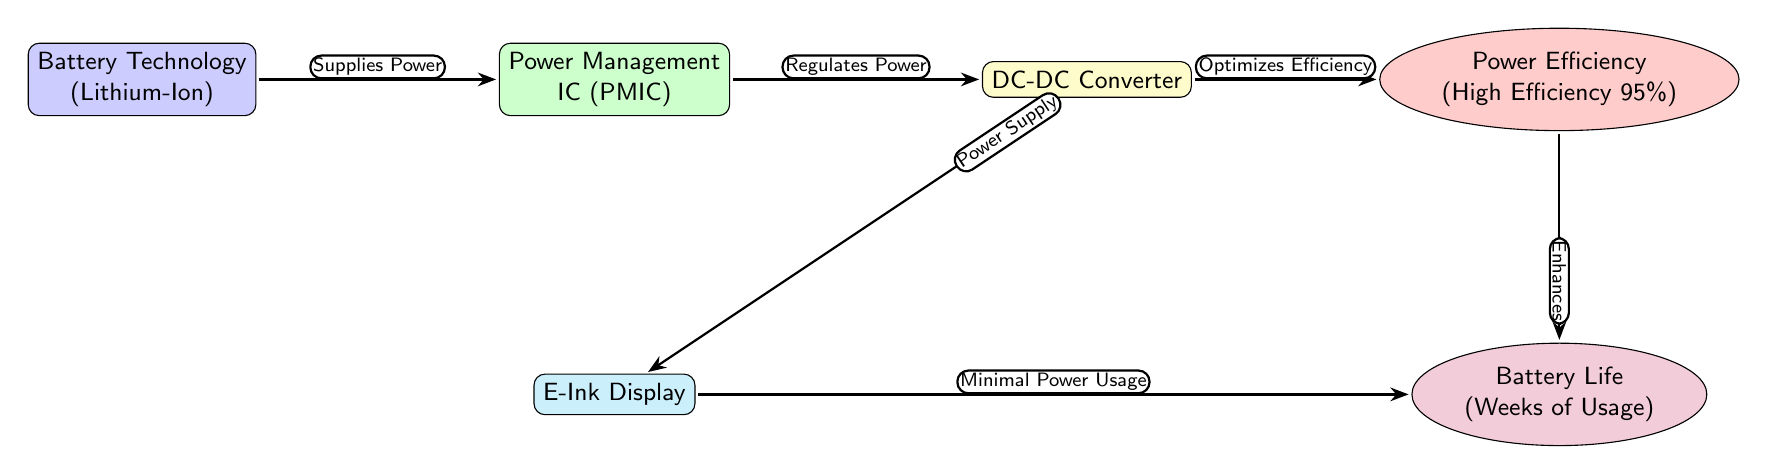What is the technology used for the battery? The diagram indicates that the battery technology is Lithium-Ion as shown in the battery node.
Answer: Lithium-Ion How many nodes are in the diagram? Counting the distinct shapes in the diagram, there are five nodes in total, which are Battery Technology, Power Management IC, DC-DC Converter, Power Efficiency, and E-Ink Display, along with the Battery Life.
Answer: Five Which component regulates power in the power management flow? The node labeled as PMIC (Power Management IC) is indicated to be responsible for regulating power as it receives power from the battery and sends it to the DC-DC Converter.
Answer: PMIC What is the power efficiency measure depicted in the diagram? The diagram specifies the power efficiency as high efficiency at a rate of 95%. This is explicitly stated in the efficiency node.
Answer: High Efficiency 95% How does the DC-DC Converter affect the E-Ink Display? The diagram shows that the DC-DC Converter supplies power directly to the E-Ink Display, indicating its role in providing necessary power for operation.
Answer: Supplies Power What relationship exists between Power Efficiency and Battery Life? The connection from the efficiency node to the battery life node indicates that improvements in power efficiency directly enhance battery life, as represented by the arrow in the diagram.
Answer: Enhances What type of display is mentioned in the diagram? Analyzing the E-Ink Display node in the diagram, it clearly states that the display type is E-Ink, reflecting the technology used in modern e-readers.
Answer: E-Ink Display What is the main benefit of the minimal power usage of the E-Ink display? The diagram indicates that the minimal power usage of the E-Ink display contributes positively to battery life, as represented by the direct link between these two nodes.
Answer: Battery Life What is the primary function of the DC-DC Converter in this context? Based on the diagram flow, the DC-DC Converter's primary function is to optimize efficiency while also providing power to the E-Ink display.
Answer: Optimizes Efficiency 